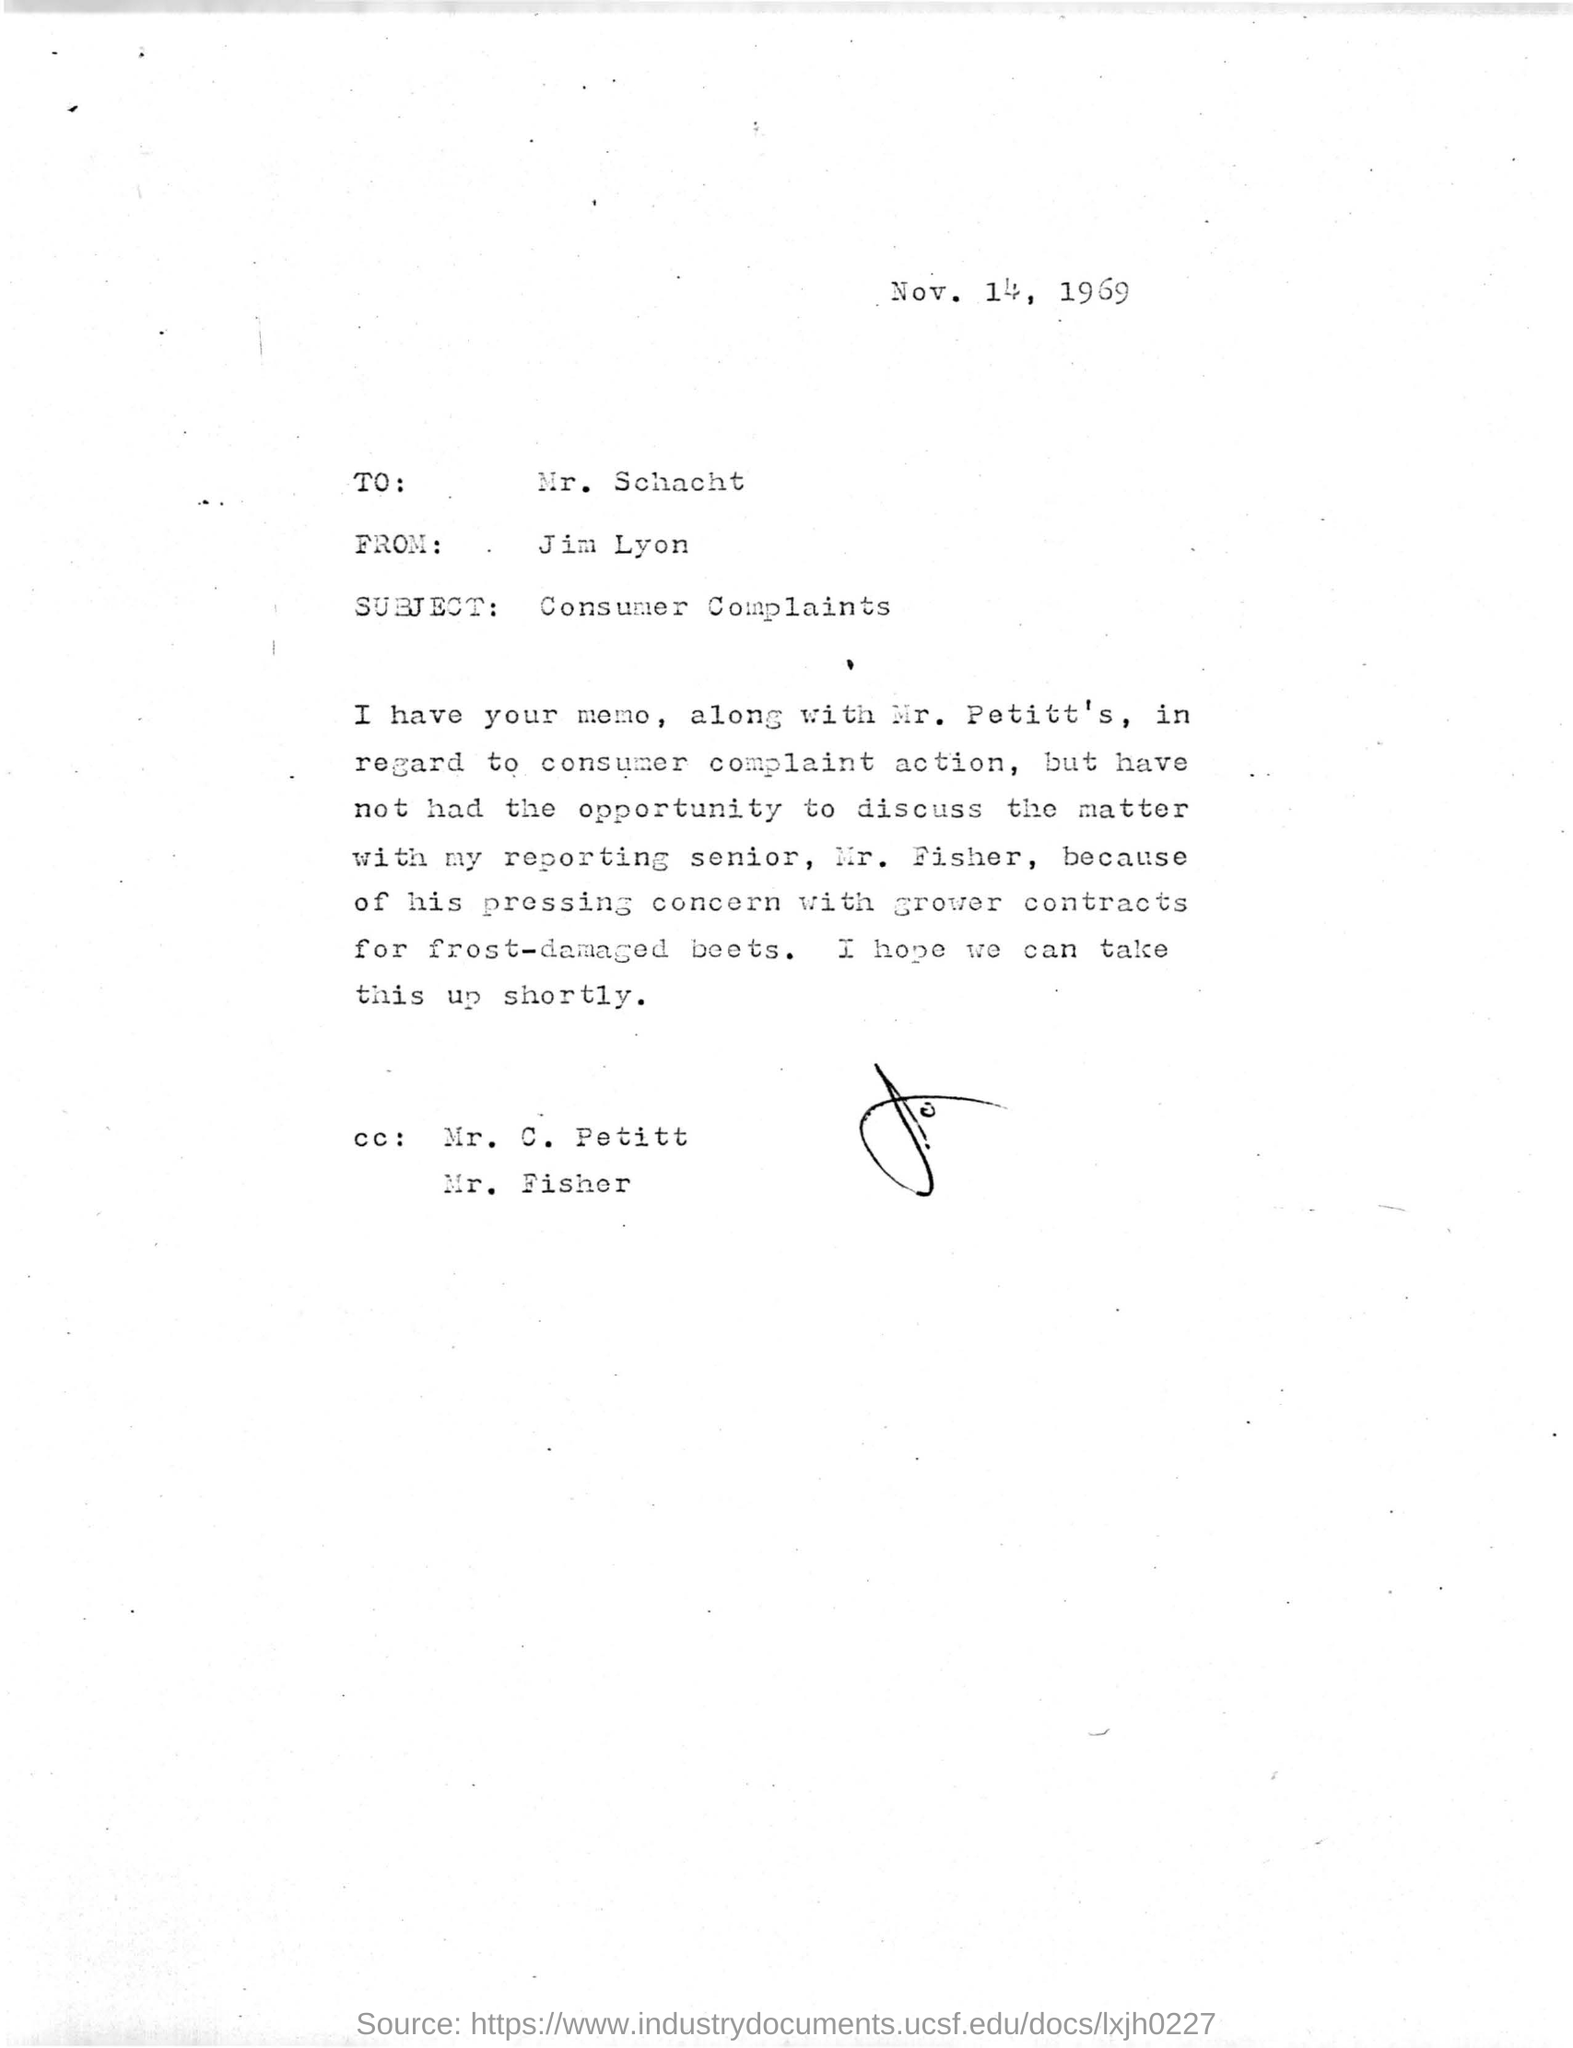Give some essential details in this illustration. The subject of the given letter is "Consumer Complaints. The letter was written on November 14th, 1969. The letter was written by Jim Lyon. This letter was written to Mr. Schacht. 